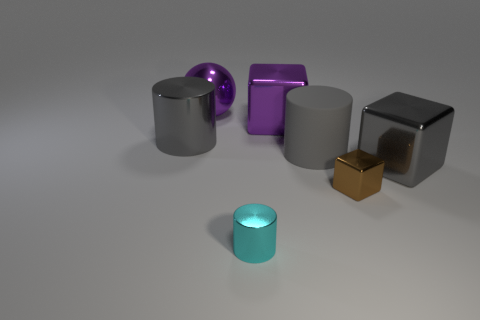Are there any other things that have the same material as the cyan object?
Make the answer very short. Yes. What size is the metal sphere?
Keep it short and to the point. Large. What is the color of the shiny block that is behind the brown metal thing and to the right of the big matte cylinder?
Ensure brevity in your answer.  Gray. Is the number of small cyan cylinders greater than the number of tiny yellow matte blocks?
Make the answer very short. Yes. How many things are either big gray rubber things or large cylinders to the right of the purple metallic block?
Provide a short and direct response. 1. Is the purple ball the same size as the cyan cylinder?
Offer a very short reply. No. There is a tiny brown thing; are there any cyan things on the right side of it?
Ensure brevity in your answer.  No. What is the size of the thing that is both behind the matte cylinder and to the right of the large shiny sphere?
Keep it short and to the point. Large. How many things are either gray blocks or tiny cyan objects?
Keep it short and to the point. 2. Is the size of the gray matte object the same as the object to the right of the brown shiny thing?
Provide a succinct answer. Yes. 